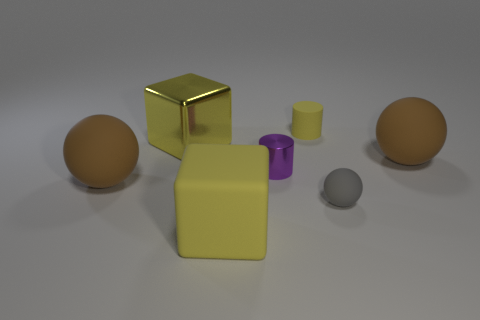Add 1 gray balls. How many objects exist? 8 Subtract all large spheres. How many spheres are left? 1 Subtract all green blocks. How many brown spheres are left? 2 Subtract all balls. How many objects are left? 4 Subtract all brown matte things. Subtract all big yellow cubes. How many objects are left? 3 Add 6 balls. How many balls are left? 9 Add 7 yellow blocks. How many yellow blocks exist? 9 Subtract 0 purple spheres. How many objects are left? 7 Subtract all cyan blocks. Subtract all red spheres. How many blocks are left? 2 